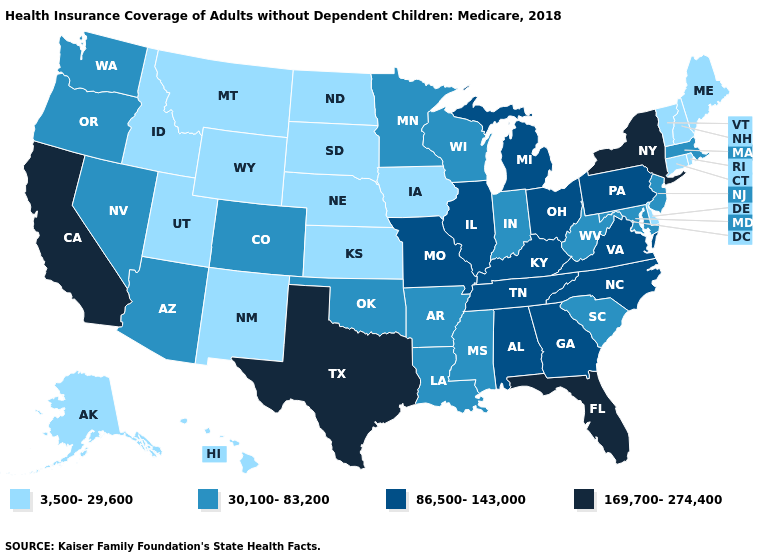How many symbols are there in the legend?
Write a very short answer. 4. What is the highest value in states that border Kansas?
Give a very brief answer. 86,500-143,000. Does New Mexico have the highest value in the USA?
Keep it brief. No. Which states have the highest value in the USA?
Keep it brief. California, Florida, New York, Texas. Name the states that have a value in the range 3,500-29,600?
Give a very brief answer. Alaska, Connecticut, Delaware, Hawaii, Idaho, Iowa, Kansas, Maine, Montana, Nebraska, New Hampshire, New Mexico, North Dakota, Rhode Island, South Dakota, Utah, Vermont, Wyoming. What is the value of Wyoming?
Keep it brief. 3,500-29,600. What is the lowest value in states that border Delaware?
Write a very short answer. 30,100-83,200. Which states have the lowest value in the South?
Be succinct. Delaware. What is the value of Wyoming?
Concise answer only. 3,500-29,600. Does Oklahoma have the lowest value in the USA?
Be succinct. No. Does Colorado have the same value as Indiana?
Quick response, please. Yes. Which states hav the highest value in the South?
Give a very brief answer. Florida, Texas. What is the value of North Dakota?
Answer briefly. 3,500-29,600. Among the states that border Oklahoma , does Colorado have the highest value?
Give a very brief answer. No. Name the states that have a value in the range 3,500-29,600?
Quick response, please. Alaska, Connecticut, Delaware, Hawaii, Idaho, Iowa, Kansas, Maine, Montana, Nebraska, New Hampshire, New Mexico, North Dakota, Rhode Island, South Dakota, Utah, Vermont, Wyoming. 